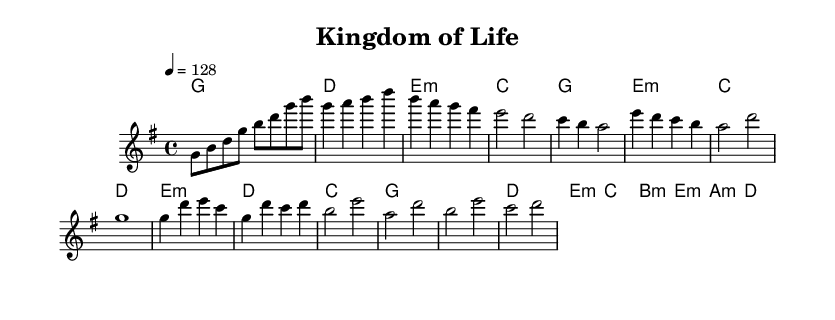What is the key signature of this music? The key signature given in the music sheet is G major, which has one sharp (F#). This can be identified from the opening of the score, where the key is indicated right before the clef and time signature.
Answer: G major What is the time signature of this music? The time signature is 4/4, shown at the beginning of the score. This indicates four beats in each measure and a quarter note gets one beat. It is a common time signature in many music styles, including K-Pop.
Answer: 4/4 What is the tempo marking of this music? The tempo marking in the music sheet indicates a speed of 128 BPM. This is explicitly stated in the tempo text at the beginning of the score. It suggests a lively pace commonly found in K-Pop tracks.
Answer: 128 How many measures are in the chorus section? The chorus section consists of 4 measures, which can be counted by identifying the music notes within that segment. Each group of musical notes separated by bar lines represents one measure.
Answer: 4 What is the harmonic structure during the verse? The harmonic structure during the verse consists of the chords G, E minor, C, and D. By analyzing the chord names written above the corresponding melody notes in the verse section, the sequence of harmonic support is revealed.
Answer: G, E minor, C, D Which musical section contains a bridge? The bridge section is explicitly labeled and occurs after the chorus, providing contrast to the other sections in both melody and harmony. Observing the flow of the music, we can identify the bridge by its unique chord progressions separate from the verse and chorus.
Answer: Bridge What is a common feature found in K-Pop concept albums reflected in this music? A common feature in K-Pop concept albums, reflected in this music, is the thematic exploration represented in the "Kingdom of Life" title, suggesting a narrative or concept that relates to biology, taxonomy, or nature. This highlights how K-Pop utilizes cohesive themes in their albums.
Answer: Thematic Exploration 